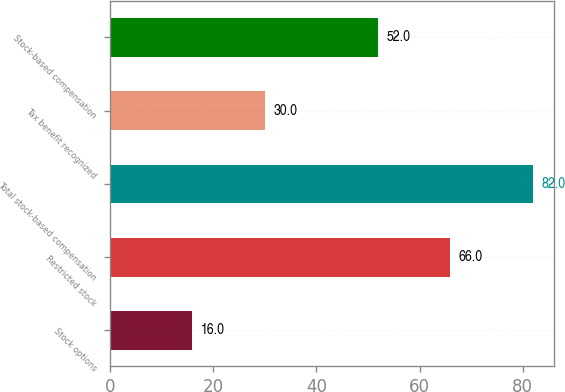<chart> <loc_0><loc_0><loc_500><loc_500><bar_chart><fcel>Stock options<fcel>Restricted stock<fcel>Total stock-based compensation<fcel>Tax benefit recognized<fcel>Stock-based compensation<nl><fcel>16<fcel>66<fcel>82<fcel>30<fcel>52<nl></chart> 